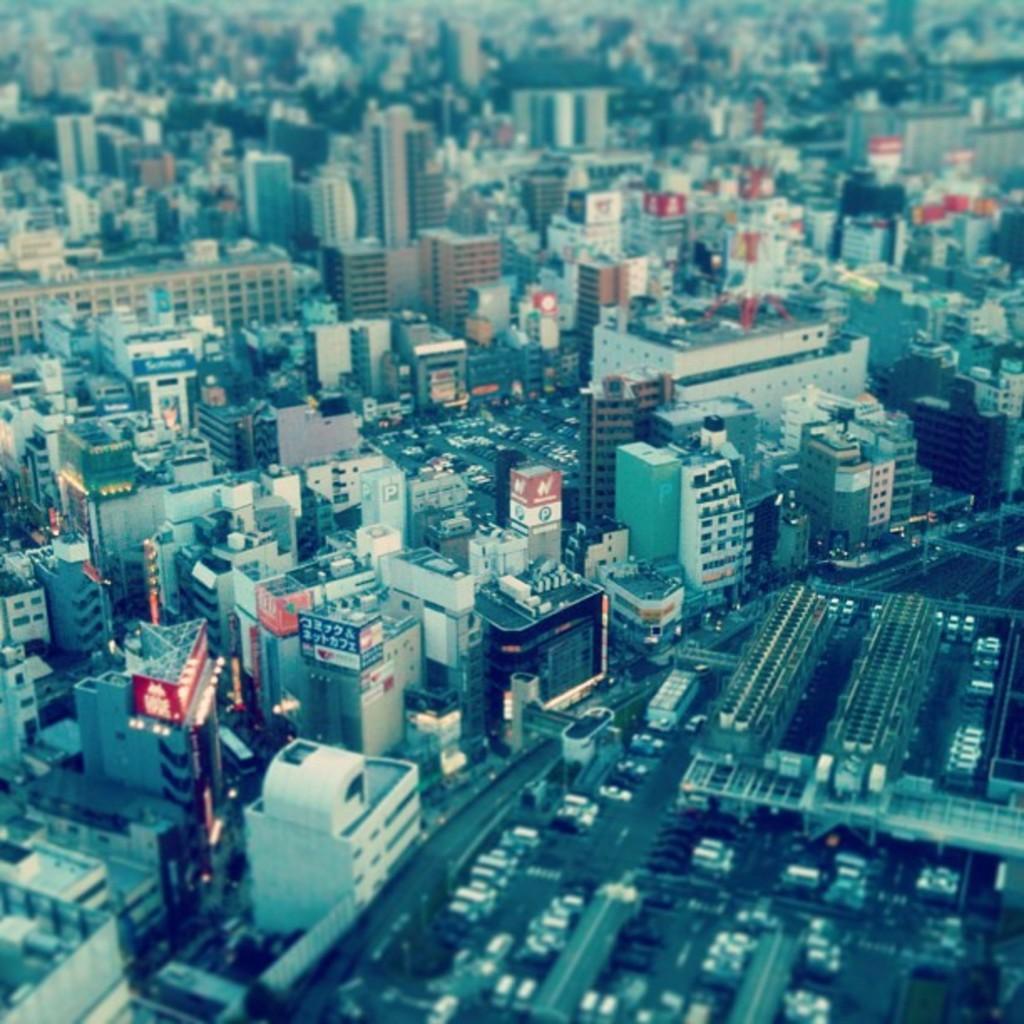Can you describe this image briefly? In this picture we can see the top view of the city. In the front there are many buildings. 